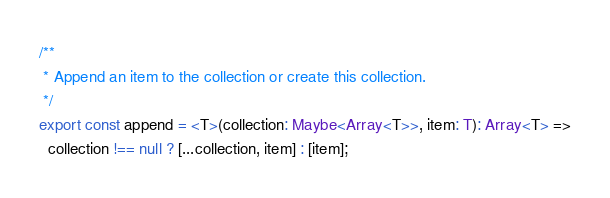Convert code to text. <code><loc_0><loc_0><loc_500><loc_500><_TypeScript_>/**
 * Append an item to the collection or create this collection.
 */
export const append = <T>(collection: Maybe<Array<T>>, item: T): Array<T> =>
  collection !== null ? [...collection, item] : [item];
</code> 